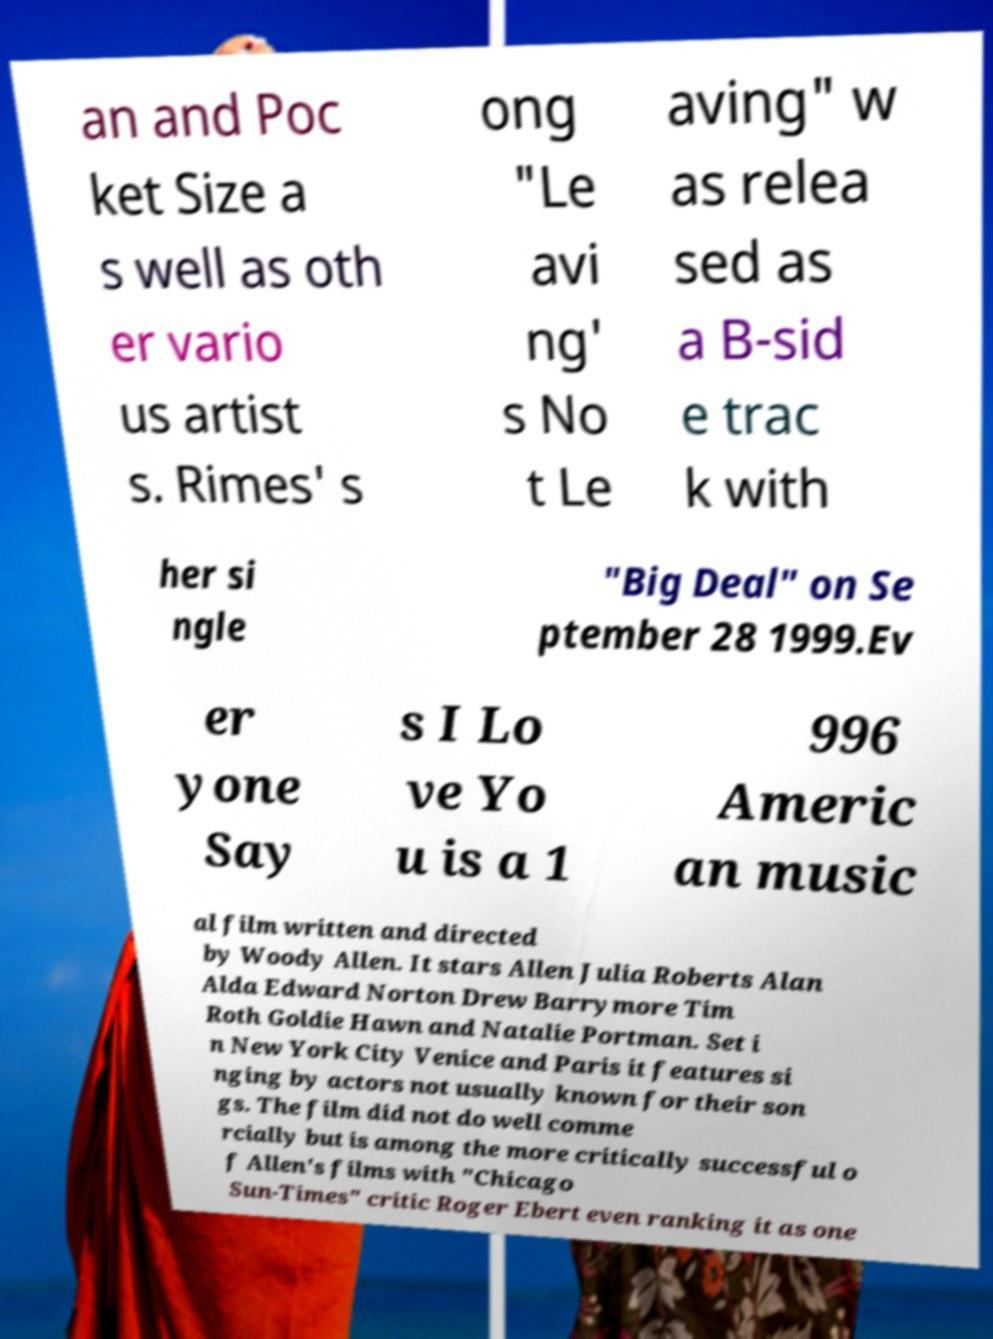Could you assist in decoding the text presented in this image and type it out clearly? an and Poc ket Size a s well as oth er vario us artist s. Rimes' s ong "Le avi ng' s No t Le aving" w as relea sed as a B-sid e trac k with her si ngle "Big Deal" on Se ptember 28 1999.Ev er yone Say s I Lo ve Yo u is a 1 996 Americ an music al film written and directed by Woody Allen. It stars Allen Julia Roberts Alan Alda Edward Norton Drew Barrymore Tim Roth Goldie Hawn and Natalie Portman. Set i n New York City Venice and Paris it features si nging by actors not usually known for their son gs. The film did not do well comme rcially but is among the more critically successful o f Allen's films with "Chicago Sun-Times" critic Roger Ebert even ranking it as one 